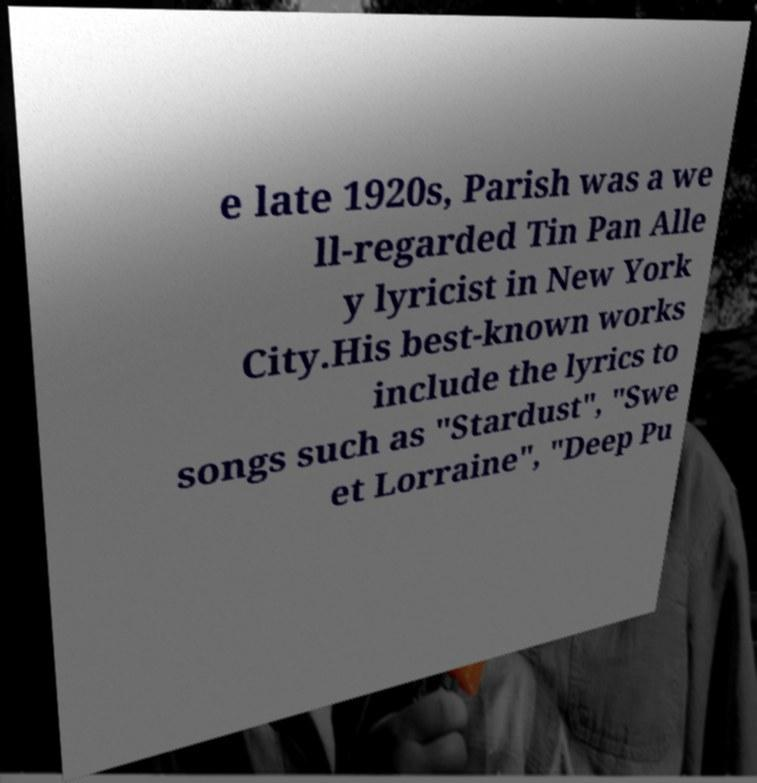I need the written content from this picture converted into text. Can you do that? e late 1920s, Parish was a we ll-regarded Tin Pan Alle y lyricist in New York City.His best-known works include the lyrics to songs such as "Stardust", "Swe et Lorraine", "Deep Pu 